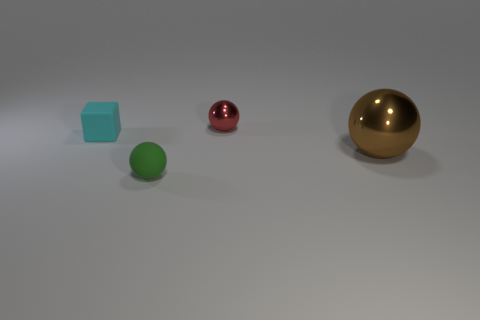Is there anything else that has the same shape as the cyan thing?
Your answer should be very brief. No. Is there a tiny rubber ball?
Provide a succinct answer. Yes. There is a shiny thing left of the metallic sphere that is right of the metallic sphere that is left of the brown thing; what size is it?
Ensure brevity in your answer.  Small. Is the shape of the big brown metallic object the same as the green thing that is in front of the large brown object?
Your answer should be very brief. Yes. How many cylinders are large cyan matte things or big brown objects?
Your response must be concise. 0. Is there another large cyan matte object that has the same shape as the big object?
Keep it short and to the point. No. Are there fewer cyan objects to the left of the small cyan block than tiny cyan rubber balls?
Provide a succinct answer. No. How many cyan rubber cubes are there?
Your answer should be very brief. 1. What number of large yellow blocks are made of the same material as the red object?
Your answer should be very brief. 0. How many things are metal balls right of the small red metallic sphere or tiny red balls?
Offer a terse response. 2. 